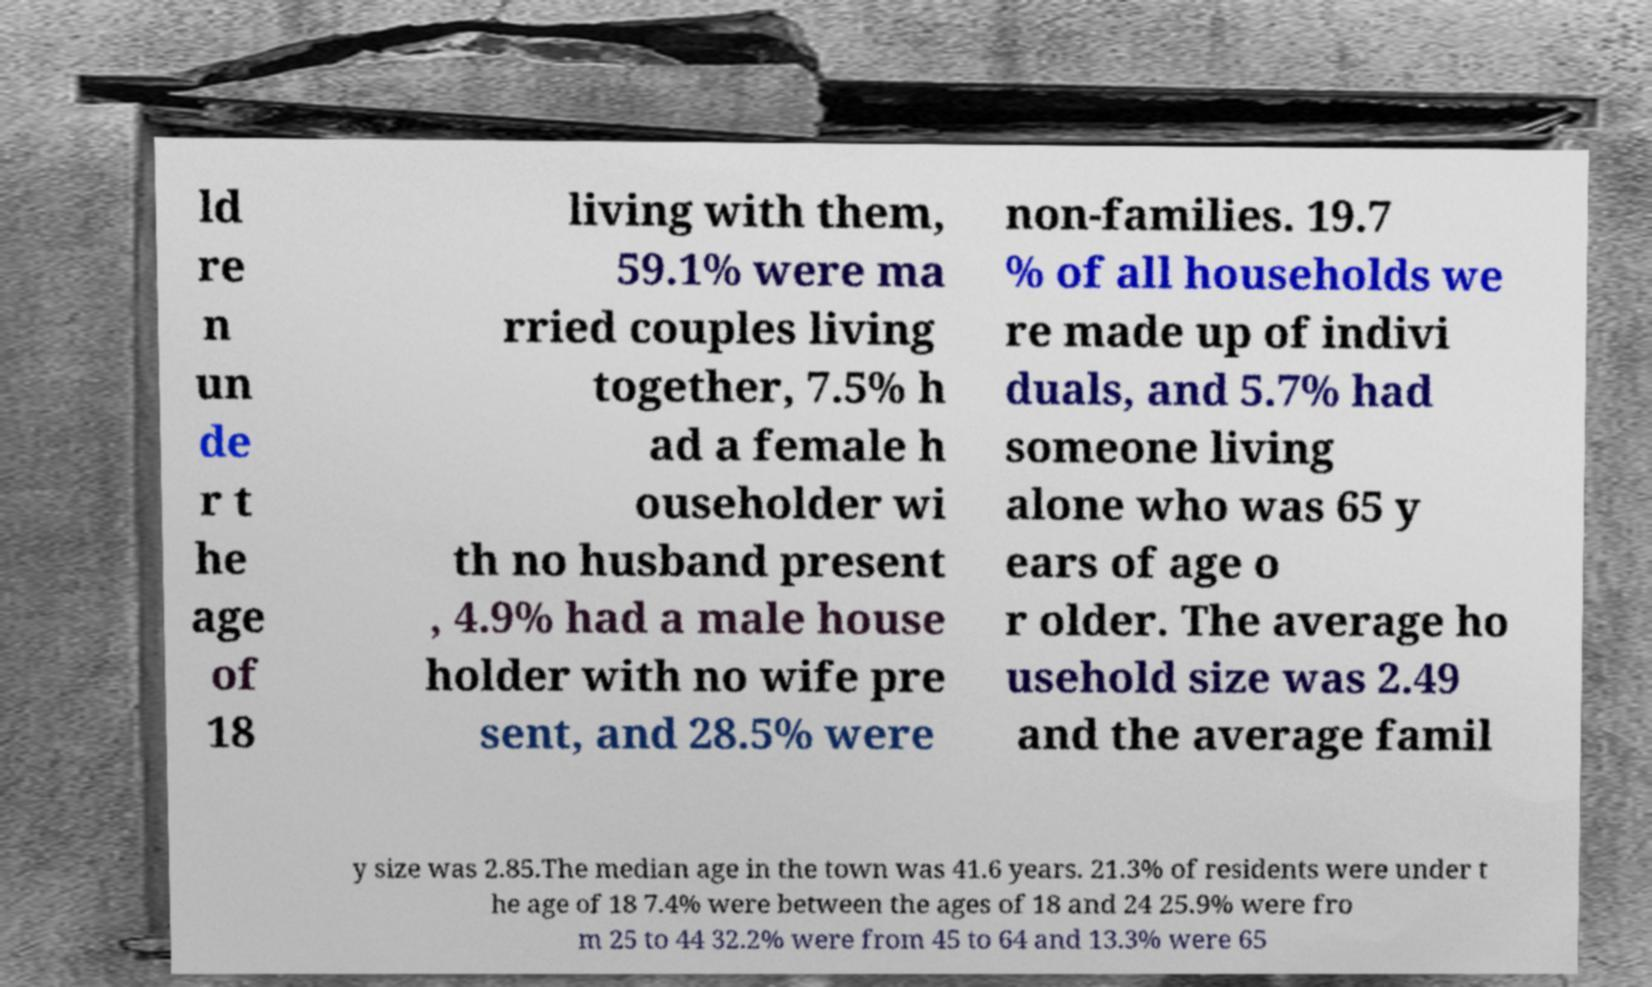I need the written content from this picture converted into text. Can you do that? ld re n un de r t he age of 18 living with them, 59.1% were ma rried couples living together, 7.5% h ad a female h ouseholder wi th no husband present , 4.9% had a male house holder with no wife pre sent, and 28.5% were non-families. 19.7 % of all households we re made up of indivi duals, and 5.7% had someone living alone who was 65 y ears of age o r older. The average ho usehold size was 2.49 and the average famil y size was 2.85.The median age in the town was 41.6 years. 21.3% of residents were under t he age of 18 7.4% were between the ages of 18 and 24 25.9% were fro m 25 to 44 32.2% were from 45 to 64 and 13.3% were 65 